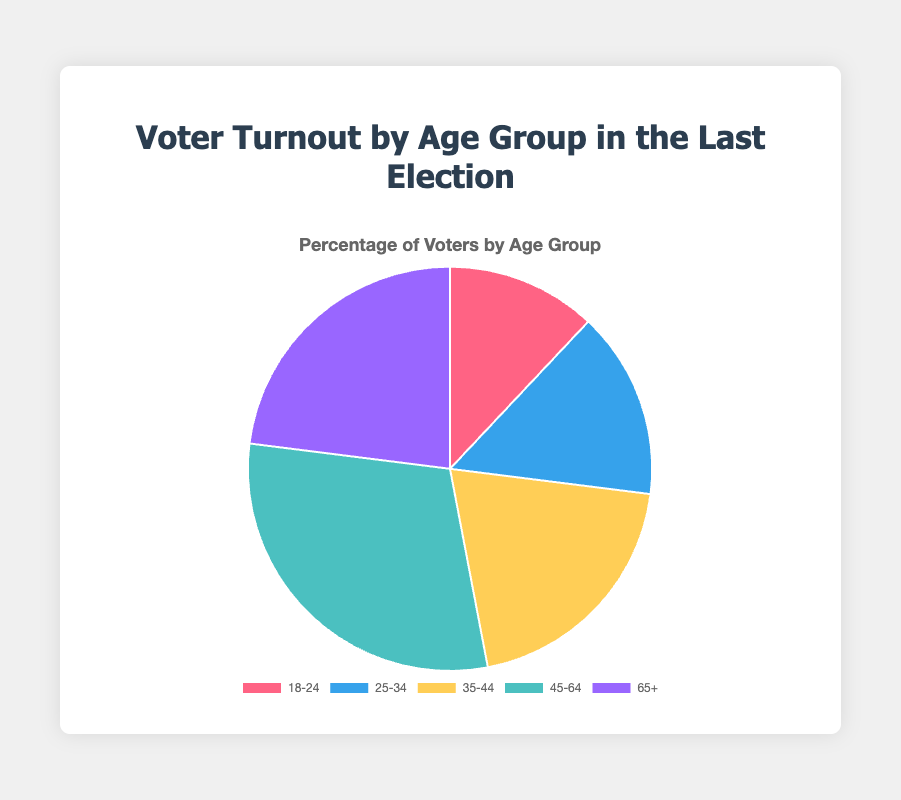Which age group had the lowest voter turnout percentage? The pie chart shows voter turnout percentages for different age groups, and the age group with the least percentage value represents the lowest voter turnout.
Answer: 18-24 Which age group had the highest voter turnout percentage? The pie chart shows voter turnout percentages for different age groups, and the age group with the highest percentage value represents the highest voter turnout.
Answer: 45-64 What is the combined voter turnout percentage for the age groups 18-24 and 25-34? Sum the percentages for the 18-24 and 25-34 age groups: 12% + 15% = 27%.
Answer: 27% How does the voter turnout for the 35-44 age group compare to the 65+ age group? Comparing the percentages of the 35-44 (20%) and 65+ (23%) age groups, we see that 65+ has a higher turnout.
Answer: 65+ is higher What is the difference between the highest and lowest voter turnout percentages? Subtract the lowest turnout percentage (12%) from the highest turnout percentage (30%): 30% - 12% = 18%.
Answer: 18% Which two age groups together constitute a combined voter turnout of approximately half? We need to find two age groups whose percentages add up to around 50%. The 45-64 (30%) and 18-24 (12%) together make 42%, and the 45-64 (30%) and 25-34 (15%) together make 45%. Finally, the 45-64 (30%) and 35-44 (20%) together make 50%.
Answer: 45-64 and 35-44 What percentage of the total voter turnout is represented by the age groups under 35? Combine the percentages of the age groups 18-24 (12%) and 25-34 (15%): 12% + 15% = 27%.
Answer: 27% Among the age groups shown, which one has a visual representation in red? Assuming the pie chart follows a common color scheme, identify the segment colored red and its corresponding age group.
Answer: 18-24 How much more is the voter turnout for 45-64 compared to 35-44? Subtract the voter turnout percentage for 35-44 (20%) from that for 45-64 (30%): 30% - 20% = 10%.
Answer: 10% Is the voter turnout for 65+ greater than the combined turnout for 18-24 and 25-34? Sum the percentages for 18-24 (12%) and 25-34 (15%): 12% + 15% = 27%. Compare this to 65+ (23%).
Answer: No 